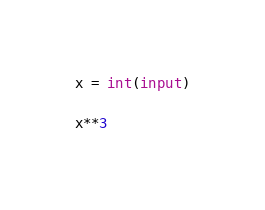<code> <loc_0><loc_0><loc_500><loc_500><_Python_>x = int(input)

x**3</code> 